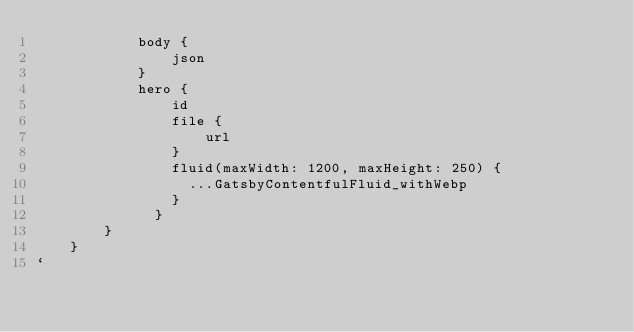Convert code to text. <code><loc_0><loc_0><loc_500><loc_500><_JavaScript_>            body {
                json
            }
            hero {
                id
                file {
                    url
                }
                fluid(maxWidth: 1200, maxHeight: 250) {
                  ...GatsbyContentfulFluid_withWebp
                }
              }
        }
    }
`</code> 